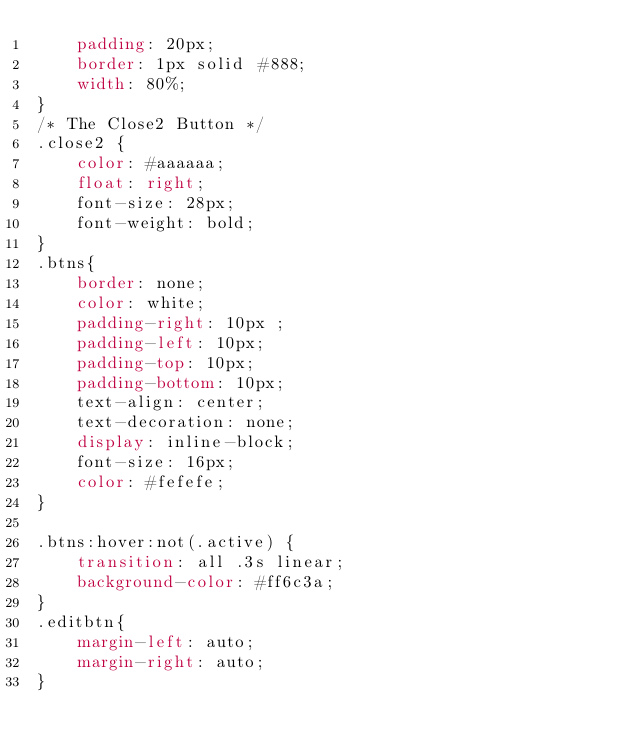<code> <loc_0><loc_0><loc_500><loc_500><_CSS_>    padding: 20px;
    border: 1px solid #888;
    width: 80%;
}
/* The Close2 Button */
.close2 {
    color: #aaaaaa;
    float: right;
    font-size: 28px;
    font-weight: bold;
}
.btns{
    border: none;
    color: white;
    padding-right: 10px ;
    padding-left: 10px;
    padding-top: 10px;
    padding-bottom: 10px;
    text-align: center;
    text-decoration: none;
    display: inline-block;
    font-size: 16px;
    color: #fefefe;
}

.btns:hover:not(.active) {
    transition: all .3s linear;
    background-color: #ff6c3a;
}
.editbtn{
    margin-left: auto;
    margin-right: auto;
}
</code> 